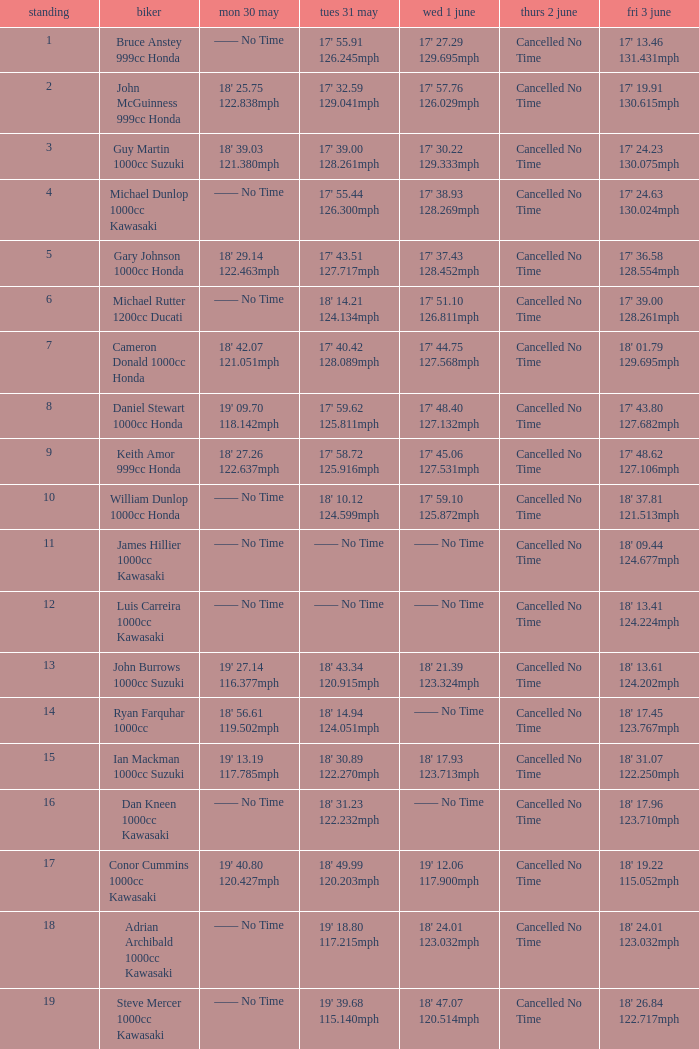What is the Thurs 2 June time for the rider with a Fri 3 June time of 17' 36.58 128.554mph? Cancelled No Time. Can you give me this table as a dict? {'header': ['standing', 'biker', 'mon 30 may', 'tues 31 may', 'wed 1 june', 'thurs 2 june', 'fri 3 june'], 'rows': [['1', 'Bruce Anstey 999cc Honda', '—— No Time', "17' 55.91 126.245mph", "17' 27.29 129.695mph", 'Cancelled No Time', "17' 13.46 131.431mph"], ['2', 'John McGuinness 999cc Honda', "18' 25.75 122.838mph", "17' 32.59 129.041mph", "17' 57.76 126.029mph", 'Cancelled No Time', "17' 19.91 130.615mph"], ['3', 'Guy Martin 1000cc Suzuki', "18' 39.03 121.380mph", "17' 39.00 128.261mph", "17' 30.22 129.333mph", 'Cancelled No Time', "17' 24.23 130.075mph"], ['4', 'Michael Dunlop 1000cc Kawasaki', '—— No Time', "17' 55.44 126.300mph", "17' 38.93 128.269mph", 'Cancelled No Time', "17' 24.63 130.024mph"], ['5', 'Gary Johnson 1000cc Honda', "18' 29.14 122.463mph", "17' 43.51 127.717mph", "17' 37.43 128.452mph", 'Cancelled No Time', "17' 36.58 128.554mph"], ['6', 'Michael Rutter 1200cc Ducati', '—— No Time', "18' 14.21 124.134mph", "17' 51.10 126.811mph", 'Cancelled No Time', "17' 39.00 128.261mph"], ['7', 'Cameron Donald 1000cc Honda', "18' 42.07 121.051mph", "17' 40.42 128.089mph", "17' 44.75 127.568mph", 'Cancelled No Time', "18' 01.79 129.695mph"], ['8', 'Daniel Stewart 1000cc Honda', "19' 09.70 118.142mph", "17' 59.62 125.811mph", "17' 48.40 127.132mph", 'Cancelled No Time', "17' 43.80 127.682mph"], ['9', 'Keith Amor 999cc Honda', "18' 27.26 122.637mph", "17' 58.72 125.916mph", "17' 45.06 127.531mph", 'Cancelled No Time', "17' 48.62 127.106mph"], ['10', 'William Dunlop 1000cc Honda', '—— No Time', "18' 10.12 124.599mph", "17' 59.10 125.872mph", 'Cancelled No Time', "18' 37.81 121.513mph"], ['11', 'James Hillier 1000cc Kawasaki', '—— No Time', '—— No Time', '—— No Time', 'Cancelled No Time', "18' 09.44 124.677mph"], ['12', 'Luis Carreira 1000cc Kawasaki', '—— No Time', '—— No Time', '—— No Time', 'Cancelled No Time', "18' 13.41 124.224mph"], ['13', 'John Burrows 1000cc Suzuki', "19' 27.14 116.377mph", "18' 43.34 120.915mph", "18' 21.39 123.324mph", 'Cancelled No Time', "18' 13.61 124.202mph"], ['14', 'Ryan Farquhar 1000cc', "18' 56.61 119.502mph", "18' 14.94 124.051mph", '—— No Time', 'Cancelled No Time', "18' 17.45 123.767mph"], ['15', 'Ian Mackman 1000cc Suzuki', "19' 13.19 117.785mph", "18' 30.89 122.270mph", "18' 17.93 123.713mph", 'Cancelled No Time', "18' 31.07 122.250mph"], ['16', 'Dan Kneen 1000cc Kawasaki', '—— No Time', "18' 31.23 122.232mph", '—— No Time', 'Cancelled No Time', "18' 17.96 123.710mph"], ['17', 'Conor Cummins 1000cc Kawasaki', "19' 40.80 120.427mph", "18' 49.99 120.203mph", "19' 12.06 117.900mph", 'Cancelled No Time', "18' 19.22 115.052mph"], ['18', 'Adrian Archibald 1000cc Kawasaki', '—— No Time', "19' 18.80 117.215mph", "18' 24.01 123.032mph", 'Cancelled No Time', "18' 24.01 123.032mph"], ['19', 'Steve Mercer 1000cc Kawasaki', '—— No Time', "19' 39.68 115.140mph", "18' 47.07 120.514mph", 'Cancelled No Time', "18' 26.84 122.717mph"]]} 